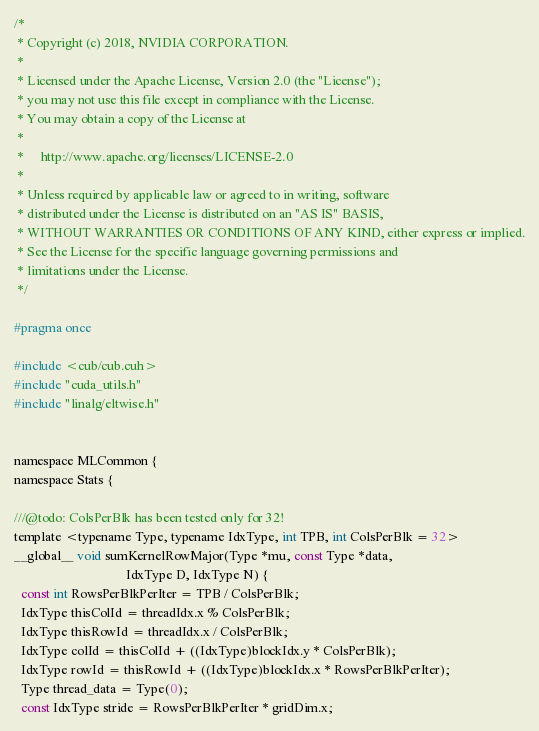Convert code to text. <code><loc_0><loc_0><loc_500><loc_500><_C_>/*
 * Copyright (c) 2018, NVIDIA CORPORATION.
 *
 * Licensed under the Apache License, Version 2.0 (the "License");
 * you may not use this file except in compliance with the License.
 * You may obtain a copy of the License at
 *
 *     http://www.apache.org/licenses/LICENSE-2.0
 *
 * Unless required by applicable law or agreed to in writing, software
 * distributed under the License is distributed on an "AS IS" BASIS,
 * WITHOUT WARRANTIES OR CONDITIONS OF ANY KIND, either express or implied.
 * See the License for the specific language governing permissions and
 * limitations under the License.
 */

#pragma once

#include <cub/cub.cuh>
#include "cuda_utils.h"
#include "linalg/eltwise.h"


namespace MLCommon {
namespace Stats {

///@todo: ColsPerBlk has been tested only for 32!
template <typename Type, typename IdxType, int TPB, int ColsPerBlk = 32>
__global__ void sumKernelRowMajor(Type *mu, const Type *data,
                                  IdxType D, IdxType N) {
  const int RowsPerBlkPerIter = TPB / ColsPerBlk;
  IdxType thisColId = threadIdx.x % ColsPerBlk;
  IdxType thisRowId = threadIdx.x / ColsPerBlk;
  IdxType colId = thisColId + ((IdxType)blockIdx.y * ColsPerBlk);
  IdxType rowId = thisRowId + ((IdxType)blockIdx.x * RowsPerBlkPerIter);
  Type thread_data = Type(0);
  const IdxType stride = RowsPerBlkPerIter * gridDim.x;</code> 